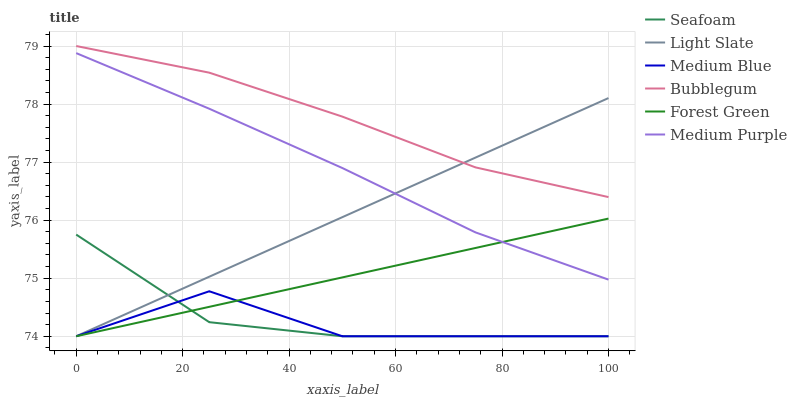Does Medium Blue have the minimum area under the curve?
Answer yes or no. Yes. Does Bubblegum have the maximum area under the curve?
Answer yes or no. Yes. Does Seafoam have the minimum area under the curve?
Answer yes or no. No. Does Seafoam have the maximum area under the curve?
Answer yes or no. No. Is Light Slate the smoothest?
Answer yes or no. Yes. Is Medium Blue the roughest?
Answer yes or no. Yes. Is Seafoam the smoothest?
Answer yes or no. No. Is Seafoam the roughest?
Answer yes or no. No. Does Bubblegum have the lowest value?
Answer yes or no. No. Does Seafoam have the highest value?
Answer yes or no. No. Is Seafoam less than Medium Purple?
Answer yes or no. Yes. Is Bubblegum greater than Seafoam?
Answer yes or no. Yes. Does Seafoam intersect Medium Purple?
Answer yes or no. No. 